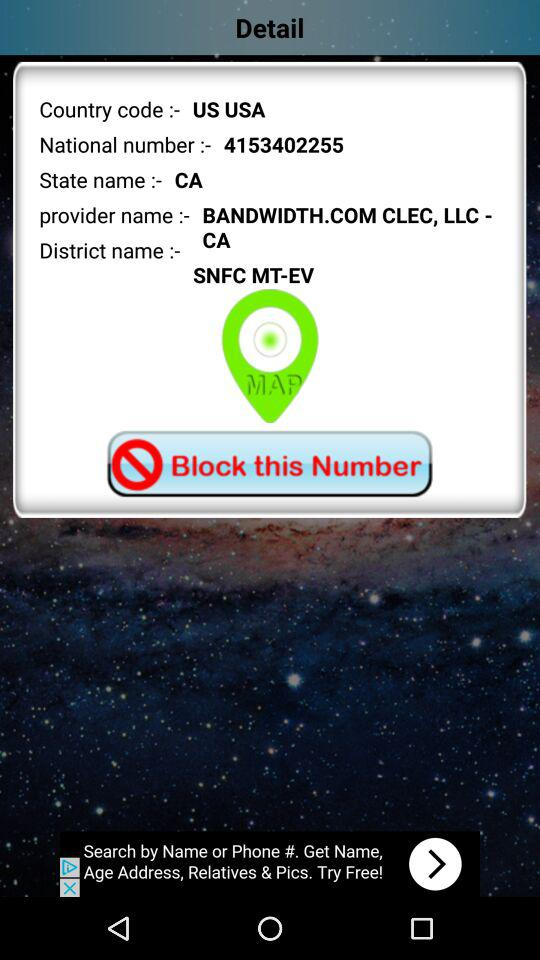What is the state name? The state name is CA. 